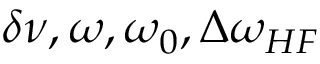Convert formula to latex. <formula><loc_0><loc_0><loc_500><loc_500>\delta \nu , \omega , \omega _ { 0 } , \Delta \omega _ { H F }</formula> 